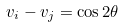<formula> <loc_0><loc_0><loc_500><loc_500>v _ { i } - v _ { j } = \cos 2 \theta</formula> 